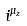Convert formula to latex. <formula><loc_0><loc_0><loc_500><loc_500>i ^ { \mu _ { z } }</formula> 